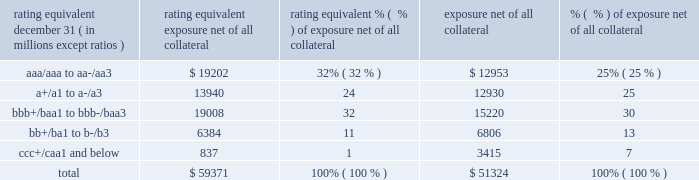Management 2019s discussion and analysis 126 jpmorgan chase & co./2014 annual report while useful as a current view of credit exposure , the net fair value of the derivative receivables does not capture the potential future variability of that credit exposure .
To capture the potential future variability of credit exposure , the firm calculates , on a client-by-client basis , three measures of potential derivatives-related credit loss : peak , derivative risk equivalent ( 201cdre 201d ) , and average exposure ( 201cavg 201d ) .
These measures all incorporate netting and collateral benefits , where applicable .
Peak exposure to a counterparty is an extreme measure of exposure calculated at a 97.5% ( 97.5 % ) confidence level .
Dre exposure is a measure that expresses the risk of derivative exposure on a basis intended to be equivalent to the risk of loan exposures .
The measurement is done by equating the unexpected loss in a derivative counterparty exposure ( which takes into consideration both the loss volatility and the credit rating of the counterparty ) with the unexpected loss in a loan exposure ( which takes into consideration only the credit rating of the counterparty ) .
Dre is a less extreme measure of potential credit loss than peak and is the primary measure used by the firm for credit approval of derivative transactions .
Finally , avg is a measure of the expected fair value of the firm 2019s derivative receivables at future time periods , including the benefit of collateral .
Avg exposure over the total life of the derivative contract is used as the primary metric for pricing purposes and is used to calculate credit capital and the cva , as further described below .
The three year avg exposure was $ 37.5 billion and $ 35.4 billion at december 31 , 2014 and 2013 , respectively , compared with derivative receivables , net of all collateral , of $ 59.4 billion and $ 51.3 billion at december 31 , 2014 and 2013 , respectively .
The fair value of the firm 2019s derivative receivables incorporates an adjustment , the cva , to reflect the credit quality of counterparties .
The cva is based on the firm 2019s avg to a counterparty and the counterparty 2019s credit spread in the credit derivatives market .
The primary components of changes in cva are credit spreads , new deal activity or unwinds , and changes in the underlying market environment .
The firm believes that active risk management is essential to controlling the dynamic credit risk in the derivatives portfolio .
In addition , the firm 2019s risk management process takes into consideration the potential impact of wrong-way risk , which is broadly defined as the potential for increased correlation between the firm 2019s exposure to a counterparty ( avg ) and the counterparty 2019s credit quality .
Many factors may influence the nature and magnitude of these correlations over time .
To the extent that these correlations are identified , the firm may adjust the cva associated with that counterparty 2019s avg .
The firm risk manages exposure to changes in cva by entering into credit derivative transactions , as well as interest rate , foreign exchange , equity and commodity derivative transactions .
The accompanying graph shows exposure profiles to the firm 2019s current derivatives portfolio over the next 10 years as calculated by the dre and avg metrics .
The two measures generally show that exposure will decline after the first year , if no new trades are added to the portfolio .
The table summarizes the ratings profile by derivative counterparty of the firm 2019s derivative receivables , including credit derivatives , net of other liquid securities collateral , for the dates indicated .
The ratings scale is based on the firm 2019s internal ratings , which generally correspond to the ratings as defined by s&p and moody 2019s .
Ratings profile of derivative receivables rating equivalent 2014 2013 ( a ) december 31 , ( in millions , except ratios ) exposure net of all collateral % (  % ) of exposure net of all collateral exposure net of all collateral % (  % ) of exposure net of all collateral .
( a ) the prior period amounts have been revised to conform with the current period presentation. .
What percent of the ratings profile of derivative receivables were junk rated in 2014? 
Computations: (11 + 1)
Answer: 12.0. 